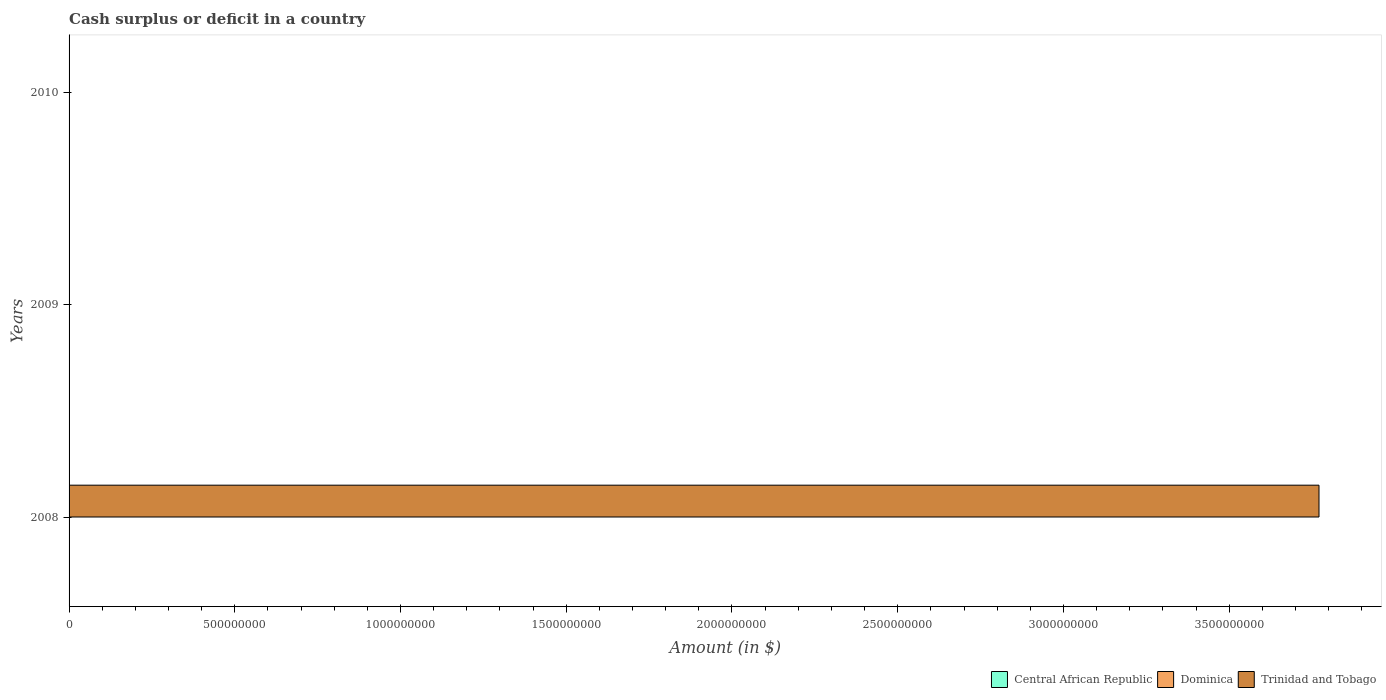Are the number of bars per tick equal to the number of legend labels?
Give a very brief answer. No. Are the number of bars on each tick of the Y-axis equal?
Offer a terse response. No. How many bars are there on the 3rd tick from the bottom?
Offer a very short reply. 0. What is the label of the 3rd group of bars from the top?
Give a very brief answer. 2008. What is the total amount of cash surplus or deficit in Trinidad and Tobago in the graph?
Ensure brevity in your answer.  3.77e+09. What is the difference between the amount of cash surplus or deficit in Trinidad and Tobago in 2010 and the amount of cash surplus or deficit in Dominica in 2008?
Your response must be concise. 0. In how many years, is the amount of cash surplus or deficit in Trinidad and Tobago greater than 2900000000 $?
Your answer should be compact. 1. In how many years, is the amount of cash surplus or deficit in Trinidad and Tobago greater than the average amount of cash surplus or deficit in Trinidad and Tobago taken over all years?
Give a very brief answer. 1. Are all the bars in the graph horizontal?
Make the answer very short. Yes. How many years are there in the graph?
Offer a terse response. 3. What is the difference between two consecutive major ticks on the X-axis?
Provide a succinct answer. 5.00e+08. Does the graph contain any zero values?
Provide a succinct answer. Yes. Does the graph contain grids?
Your answer should be very brief. No. What is the title of the graph?
Give a very brief answer. Cash surplus or deficit in a country. What is the label or title of the X-axis?
Keep it short and to the point. Amount (in $). What is the Amount (in $) of Central African Republic in 2008?
Ensure brevity in your answer.  0. What is the Amount (in $) in Dominica in 2008?
Provide a short and direct response. 0. What is the Amount (in $) of Trinidad and Tobago in 2008?
Give a very brief answer. 3.77e+09. What is the Amount (in $) in Trinidad and Tobago in 2009?
Give a very brief answer. 0. What is the Amount (in $) in Central African Republic in 2010?
Your response must be concise. 0. What is the Amount (in $) in Trinidad and Tobago in 2010?
Keep it short and to the point. 0. Across all years, what is the maximum Amount (in $) of Trinidad and Tobago?
Provide a succinct answer. 3.77e+09. Across all years, what is the minimum Amount (in $) of Trinidad and Tobago?
Your response must be concise. 0. What is the total Amount (in $) in Central African Republic in the graph?
Offer a terse response. 0. What is the total Amount (in $) of Trinidad and Tobago in the graph?
Ensure brevity in your answer.  3.77e+09. What is the average Amount (in $) in Dominica per year?
Your answer should be very brief. 0. What is the average Amount (in $) in Trinidad and Tobago per year?
Give a very brief answer. 1.26e+09. What is the difference between the highest and the lowest Amount (in $) in Trinidad and Tobago?
Offer a very short reply. 3.77e+09. 